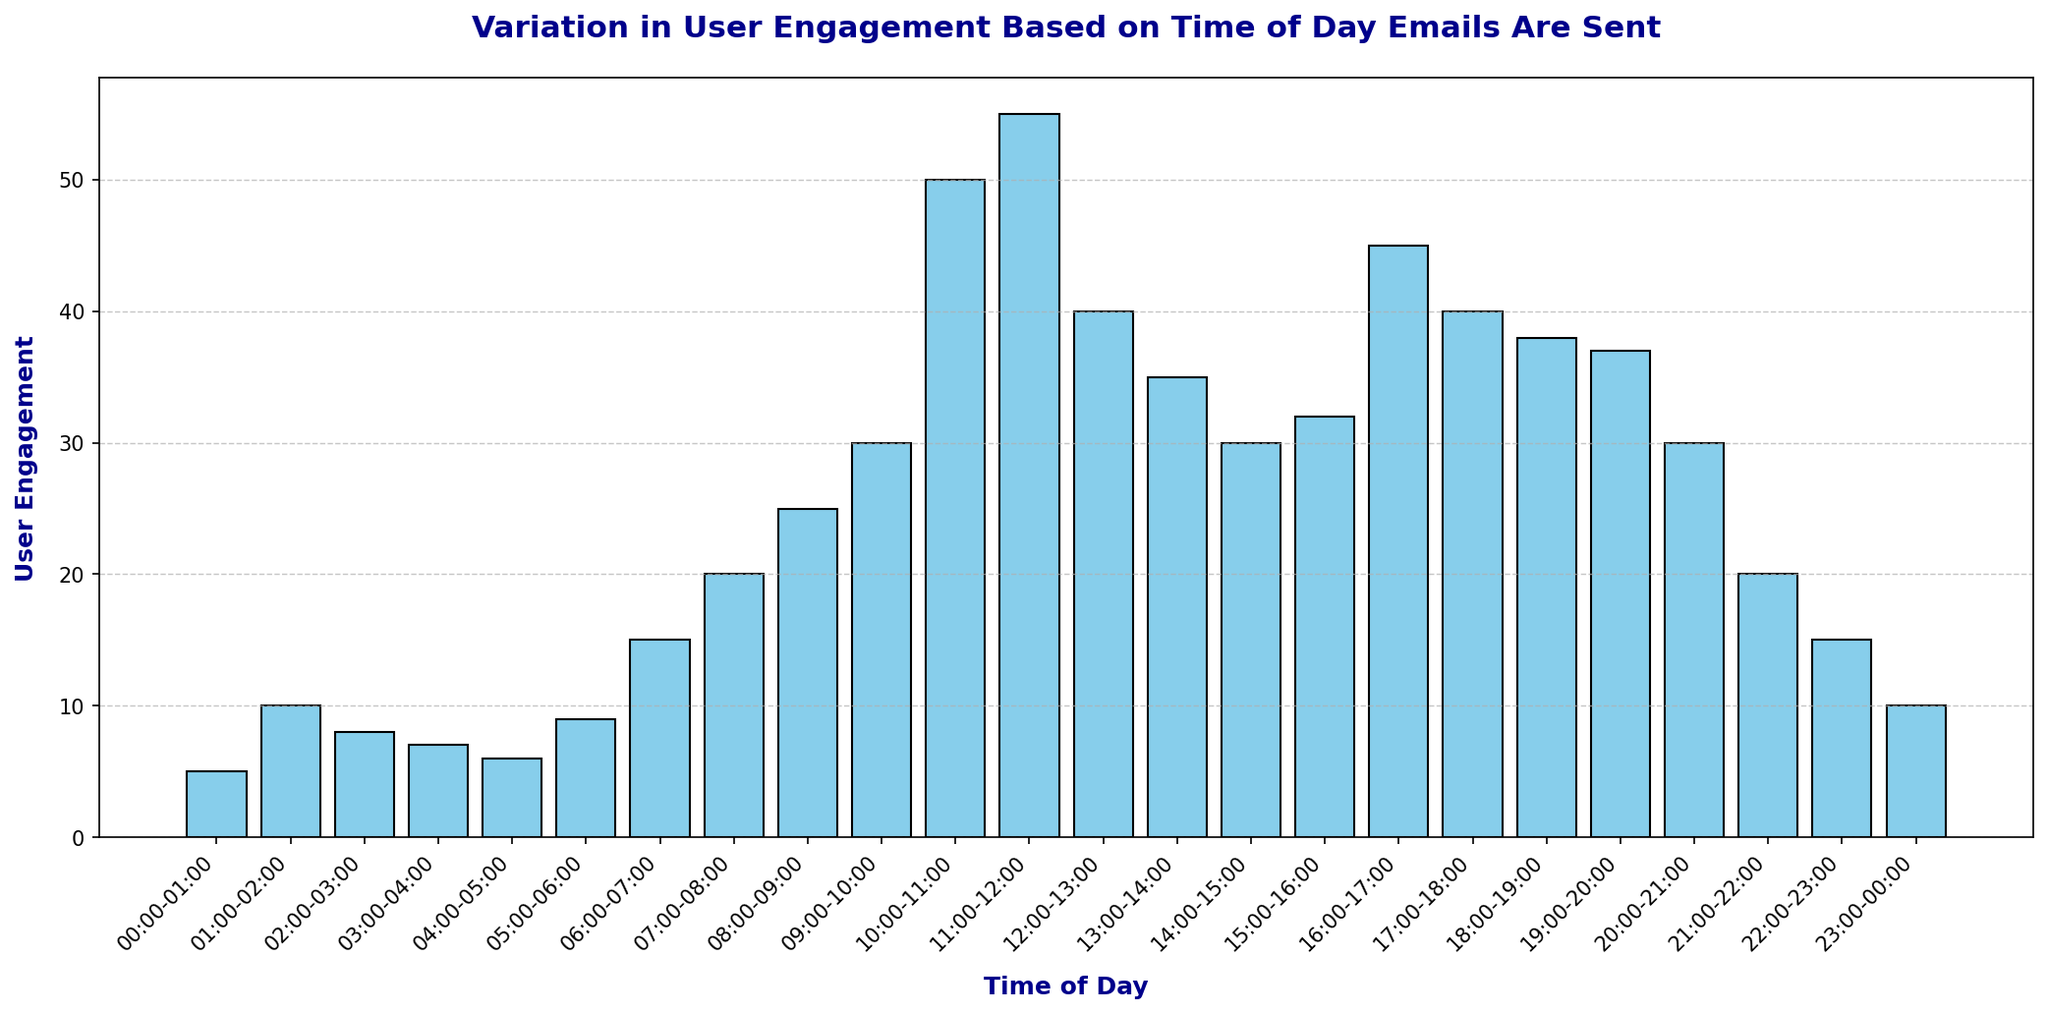When is the peak user engagement observed? Observing the histogram, the peak engagement is represented by the highest bar, which is at the time interval 11:00-12:00.
Answer: 11:00-12:00 How many times greater is user engagement at 10:00-11:00 compared to 01:00-02:00? User engagement at 10:00-11:00 is 50 and at 01:00-02:00 is 10. Dividing 50 by 10 gives us 5.
Answer: 5 times What is the average user engagement between 06:00-07:00 and 09:00-10:00? Engagements are 15 and 30 respectively. Sum them (15 + 30 = 45) and divide by 2 to find the average: 45/2=22.5.
Answer: 22.5 Which time slots have the same user engagement of 30? Checking the graph, the bars representing 09:00-10:00, 14:00-15:00, 20:00-21:00 time slots all have the same engagement of 30.
Answer: 09:00-10:00, 14:00-15:00, 20:00-21:00 What's the total user engagement from 00:00-01:00 to 05:00-06:00? Adding engagements: 5 + 10 + 8 + 7 + 6 + 9 = 45.
Answer: 45 Is user engagement higher at 13:00-14:00 or 18:00-19:00? At 13:00-14:00, engagement is 35, and at 18:00-19:00 it is 38. Therefore, 18:00-19:00 is higher.
Answer: 18:00-19:00 What is the difference in user engagement between 07:00-08:00 and 17:00-18:00? Engagement at 07:00-08:00 is 20, and at 17:00-18:00 it is 40. Subtracting these gives 20.
Answer: 20 What visual attribute indicates higher user engagement in the histogram? The height of the bars indicates higher user engagement; taller bars represent higher engagement.
Answer: Height of the bars Which two consecutive hours show the largest increase in user engagement? From 09:00-10:00 to 10:00-11:00, engagement jumps from 30 to 50, an increase of 20. This is the largest increase compared to any other consecutive hours.
Answer: 09:00-10:00 to 10:00-11:00 